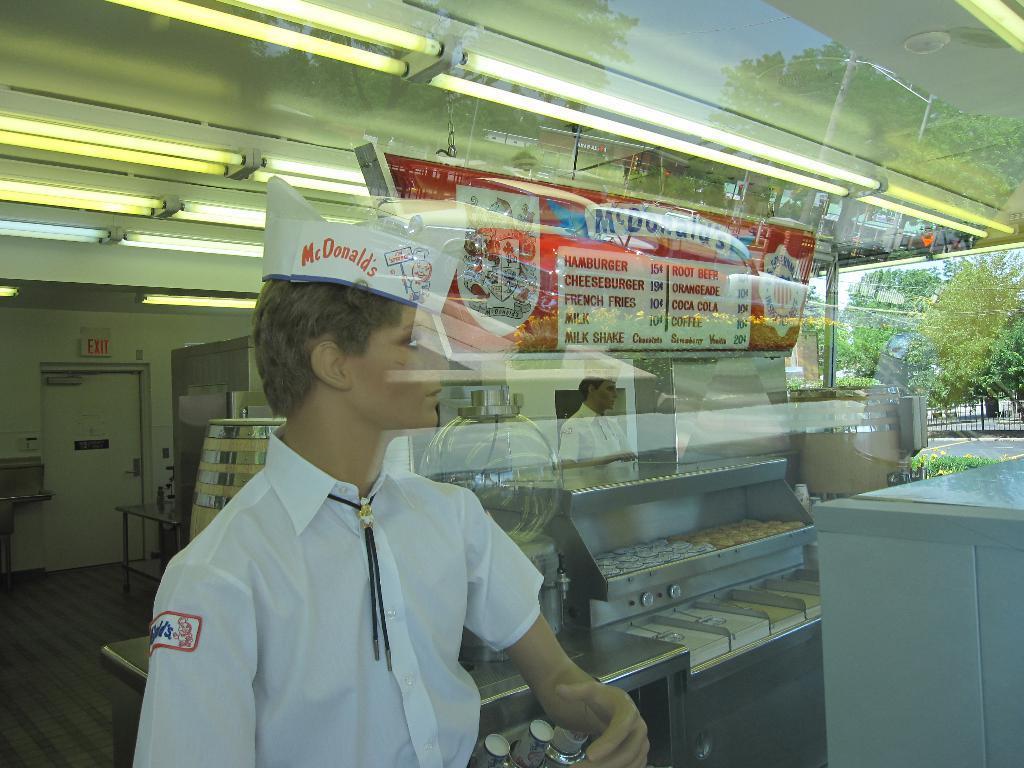Can you describe this image briefly? In this picture I can see the mirror, in which I can see the reflection of a two people and we can see some tables, lights to the roof. 